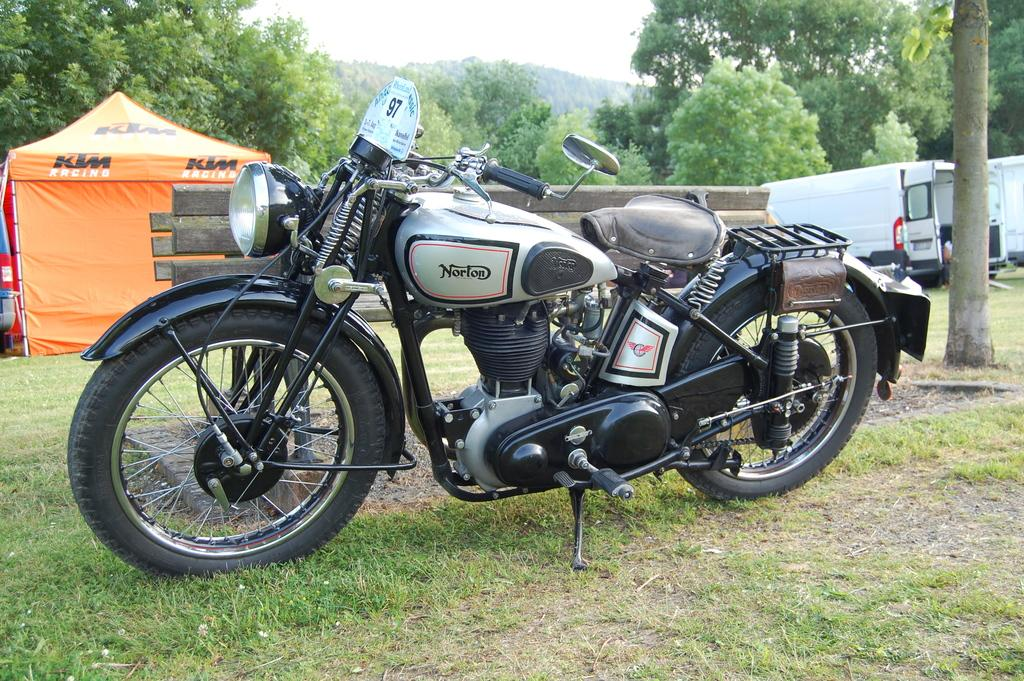What types of objects are on the ground in the image? There are vehicles on the ground in the image. What can be seen in the distance behind the vehicles? There are trees visible in the background of the image. What else is visible in the background of the image? The sky is visible in the background of the image. What type of paper can be seen flying in the image? There is no paper visible in the image; it only features vehicles, trees, and the sky. 